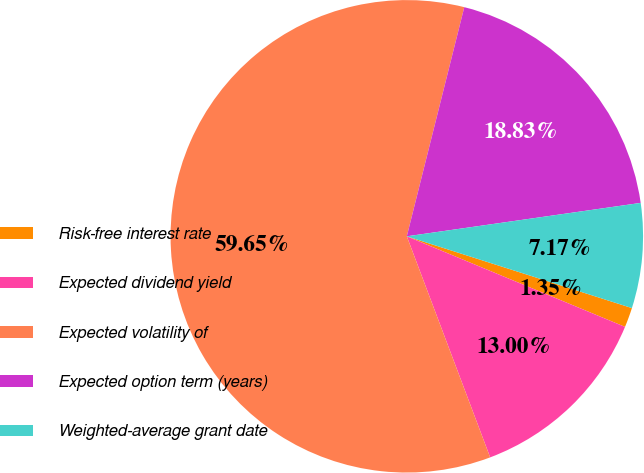<chart> <loc_0><loc_0><loc_500><loc_500><pie_chart><fcel>Risk-free interest rate<fcel>Expected dividend yield<fcel>Expected volatility of<fcel>Expected option term (years)<fcel>Weighted-average grant date<nl><fcel>1.35%<fcel>13.0%<fcel>59.65%<fcel>18.83%<fcel>7.17%<nl></chart> 